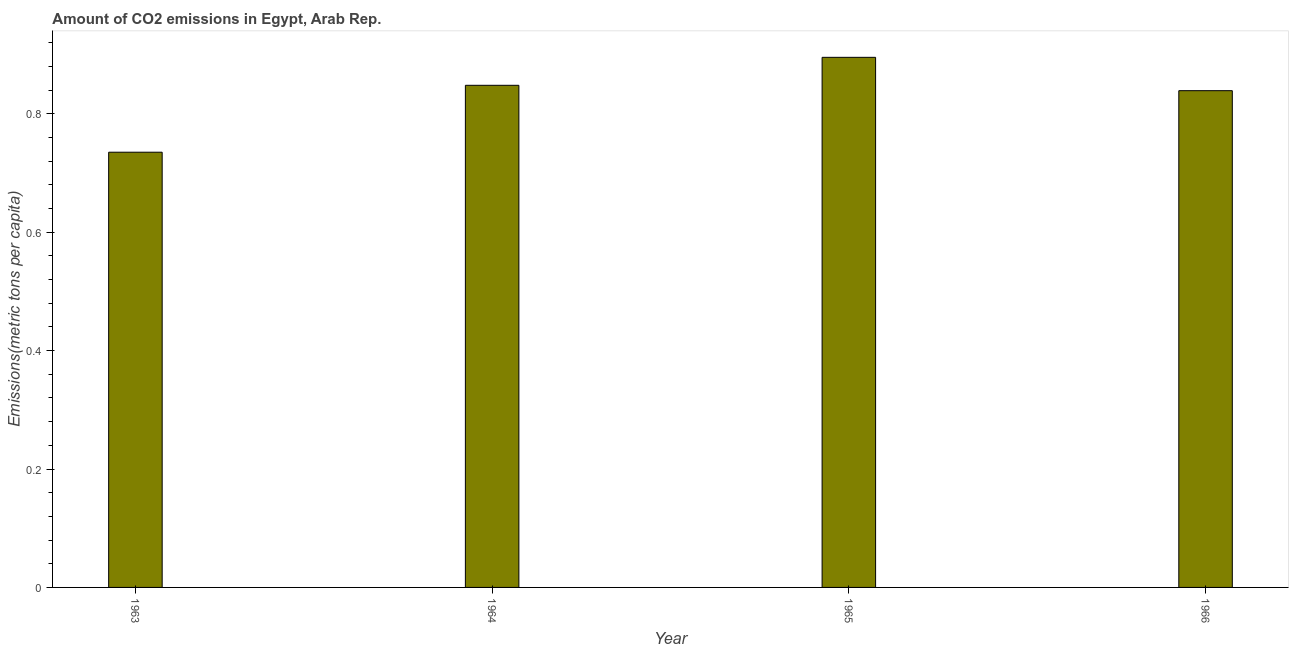Does the graph contain grids?
Provide a short and direct response. No. What is the title of the graph?
Provide a short and direct response. Amount of CO2 emissions in Egypt, Arab Rep. What is the label or title of the X-axis?
Offer a terse response. Year. What is the label or title of the Y-axis?
Make the answer very short. Emissions(metric tons per capita). What is the amount of co2 emissions in 1963?
Offer a terse response. 0.74. Across all years, what is the maximum amount of co2 emissions?
Offer a terse response. 0.9. Across all years, what is the minimum amount of co2 emissions?
Make the answer very short. 0.74. In which year was the amount of co2 emissions maximum?
Give a very brief answer. 1965. In which year was the amount of co2 emissions minimum?
Keep it short and to the point. 1963. What is the sum of the amount of co2 emissions?
Keep it short and to the point. 3.32. What is the difference between the amount of co2 emissions in 1963 and 1964?
Offer a very short reply. -0.11. What is the average amount of co2 emissions per year?
Your answer should be very brief. 0.83. What is the median amount of co2 emissions?
Your response must be concise. 0.84. In how many years, is the amount of co2 emissions greater than 0.6 metric tons per capita?
Make the answer very short. 4. Do a majority of the years between 1964 and 1963 (inclusive) have amount of co2 emissions greater than 0.56 metric tons per capita?
Make the answer very short. No. What is the ratio of the amount of co2 emissions in 1965 to that in 1966?
Ensure brevity in your answer.  1.07. Is the amount of co2 emissions in 1964 less than that in 1965?
Offer a very short reply. Yes. What is the difference between the highest and the second highest amount of co2 emissions?
Ensure brevity in your answer.  0.05. Is the sum of the amount of co2 emissions in 1964 and 1966 greater than the maximum amount of co2 emissions across all years?
Offer a terse response. Yes. What is the difference between the highest and the lowest amount of co2 emissions?
Offer a very short reply. 0.16. In how many years, is the amount of co2 emissions greater than the average amount of co2 emissions taken over all years?
Your response must be concise. 3. How many bars are there?
Make the answer very short. 4. How many years are there in the graph?
Offer a very short reply. 4. Are the values on the major ticks of Y-axis written in scientific E-notation?
Your answer should be very brief. No. What is the Emissions(metric tons per capita) of 1963?
Provide a succinct answer. 0.74. What is the Emissions(metric tons per capita) of 1964?
Your answer should be very brief. 0.85. What is the Emissions(metric tons per capita) in 1965?
Provide a succinct answer. 0.9. What is the Emissions(metric tons per capita) in 1966?
Your answer should be very brief. 0.84. What is the difference between the Emissions(metric tons per capita) in 1963 and 1964?
Make the answer very short. -0.11. What is the difference between the Emissions(metric tons per capita) in 1963 and 1965?
Ensure brevity in your answer.  -0.16. What is the difference between the Emissions(metric tons per capita) in 1963 and 1966?
Your answer should be compact. -0.1. What is the difference between the Emissions(metric tons per capita) in 1964 and 1965?
Keep it short and to the point. -0.05. What is the difference between the Emissions(metric tons per capita) in 1964 and 1966?
Your response must be concise. 0.01. What is the difference between the Emissions(metric tons per capita) in 1965 and 1966?
Keep it short and to the point. 0.06. What is the ratio of the Emissions(metric tons per capita) in 1963 to that in 1964?
Provide a succinct answer. 0.87. What is the ratio of the Emissions(metric tons per capita) in 1963 to that in 1965?
Your answer should be compact. 0.82. What is the ratio of the Emissions(metric tons per capita) in 1963 to that in 1966?
Give a very brief answer. 0.88. What is the ratio of the Emissions(metric tons per capita) in 1964 to that in 1965?
Provide a short and direct response. 0.95. What is the ratio of the Emissions(metric tons per capita) in 1964 to that in 1966?
Your answer should be compact. 1.01. What is the ratio of the Emissions(metric tons per capita) in 1965 to that in 1966?
Offer a very short reply. 1.07. 